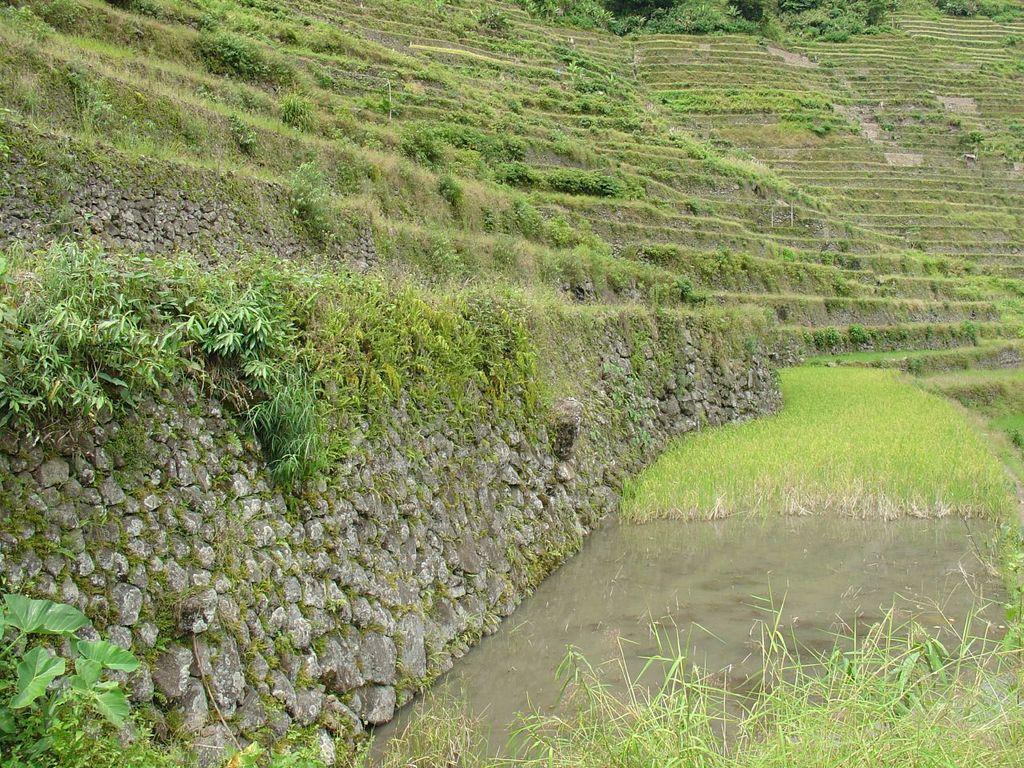How would you summarize this image in a sentence or two? In this picture, there is a hill with stones and grass. At the bottom right, there is a pond and plants. 